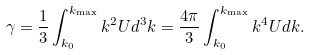Convert formula to latex. <formula><loc_0><loc_0><loc_500><loc_500>\gamma = \frac { 1 } { 3 } \int _ { k _ { 0 } } ^ { k _ { \max } } k ^ { 2 } U d ^ { 3 } k = \frac { 4 \pi } { 3 } \int _ { k _ { 0 } } ^ { k _ { \max } } k ^ { 4 } U d k .</formula> 